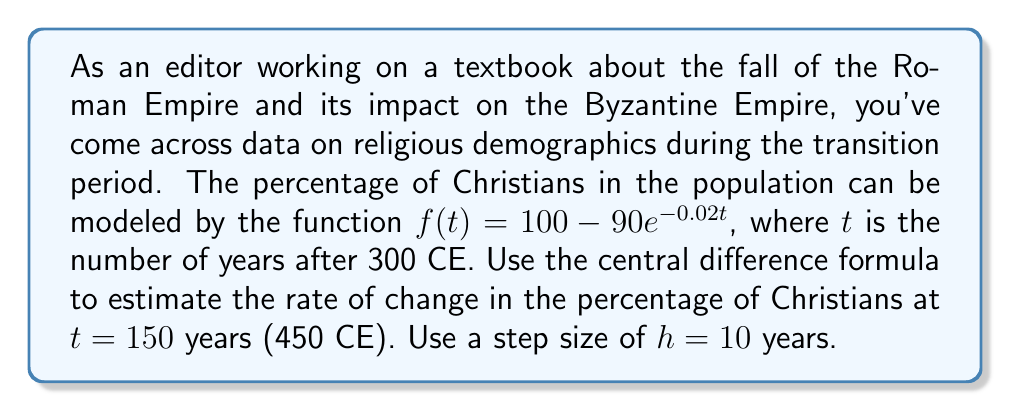Solve this math problem. To solve this problem, we'll use the central difference formula for numerical differentiation:

$$f'(t) \approx \frac{f(t+h) - f(t-h)}{2h}$$

Where $f'(t)$ is the rate of change at time $t$, and $h$ is the step size.

Given:
- $f(t) = 100 - 90e^{-0.02t}$
- $t = 150$ years
- $h = 10$ years

Step 1: Calculate $f(t+h)$
$f(150+10) = f(160) = 100 - 90e^{-0.02(160)} = 100 - 90e^{-3.2} \approx 96.0377$

Step 2: Calculate $f(t-h)$
$f(150-10) = f(140) = 100 - 90e^{-0.02(140)} = 100 - 90e^{-2.8} \approx 94.9477$

Step 3: Apply the central difference formula
$$f'(150) \approx \frac{f(160) - f(140)}{2(10)} = \frac{96.0377 - 94.9477}{20} \approx 0.0545$$

This result represents the estimated rate of change in the percentage of Christians at 450 CE, measured in percentage points per year.
Answer: The estimated rate of change in the percentage of Christians at 450 CE is approximately 0.0545 percentage points per year. 